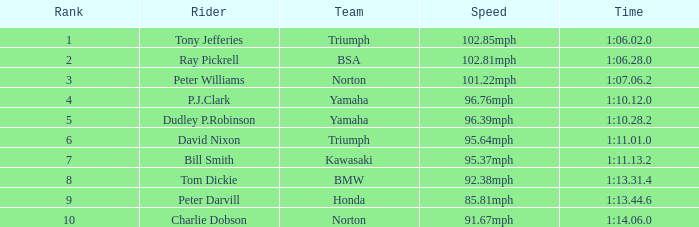How many Ranks have ray pickrell as a Rider? 1.0. 